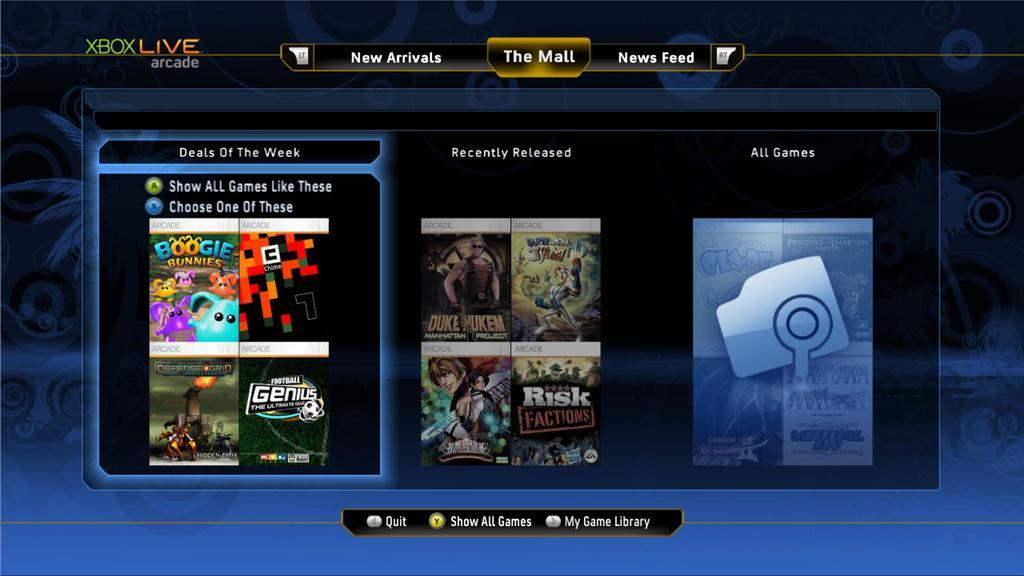What is the main object in the image? There is a screen in the image. What can be seen on the screen? The screen displays a few options of games and some text. Can you describe the text on the screen? Unfortunately, the specific text on the screen cannot be determined from the provided facts. What type of shoe is visible on the screen? There is no shoe present on the screen. The image only features a screen displaying a few options of games and some text. 